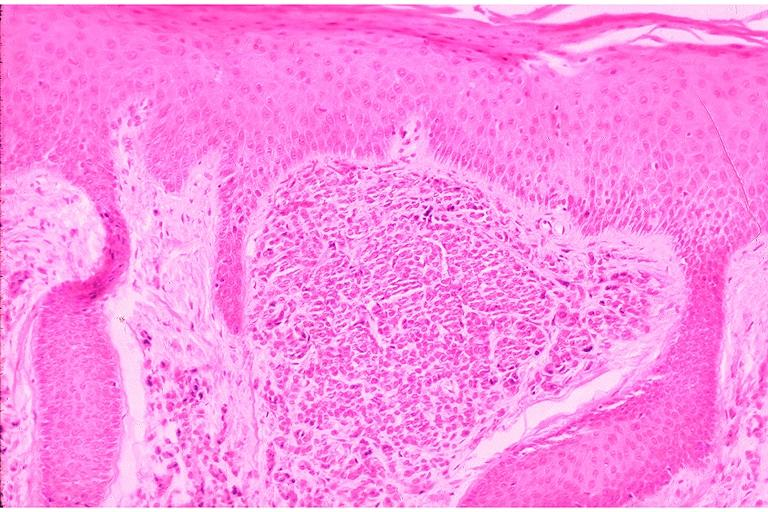does opened larynx show intramucosal nevus?
Answer the question using a single word or phrase. No 